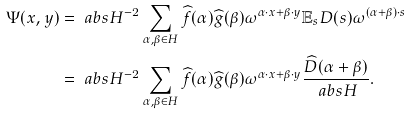<formula> <loc_0><loc_0><loc_500><loc_500>\Psi ( x , y ) & = \ a b s { H } ^ { - 2 } \sum _ { \alpha , \beta \in H } \widehat { f } ( \alpha ) \widehat { g } ( \beta ) \omega ^ { \alpha \cdot x + \beta \cdot y } \mathbb { E } _ { s } D ( s ) \omega ^ { ( \alpha + \beta ) \cdot s } \\ & = \ a b s { H } ^ { - 2 } \sum _ { \alpha , \beta \in H } \widehat { f } ( \alpha ) \widehat { g } ( \beta ) \omega ^ { \alpha \cdot x + \beta \cdot y } \frac { \widehat { D } ( \alpha + \beta ) } { \ a b s { H } } .</formula> 